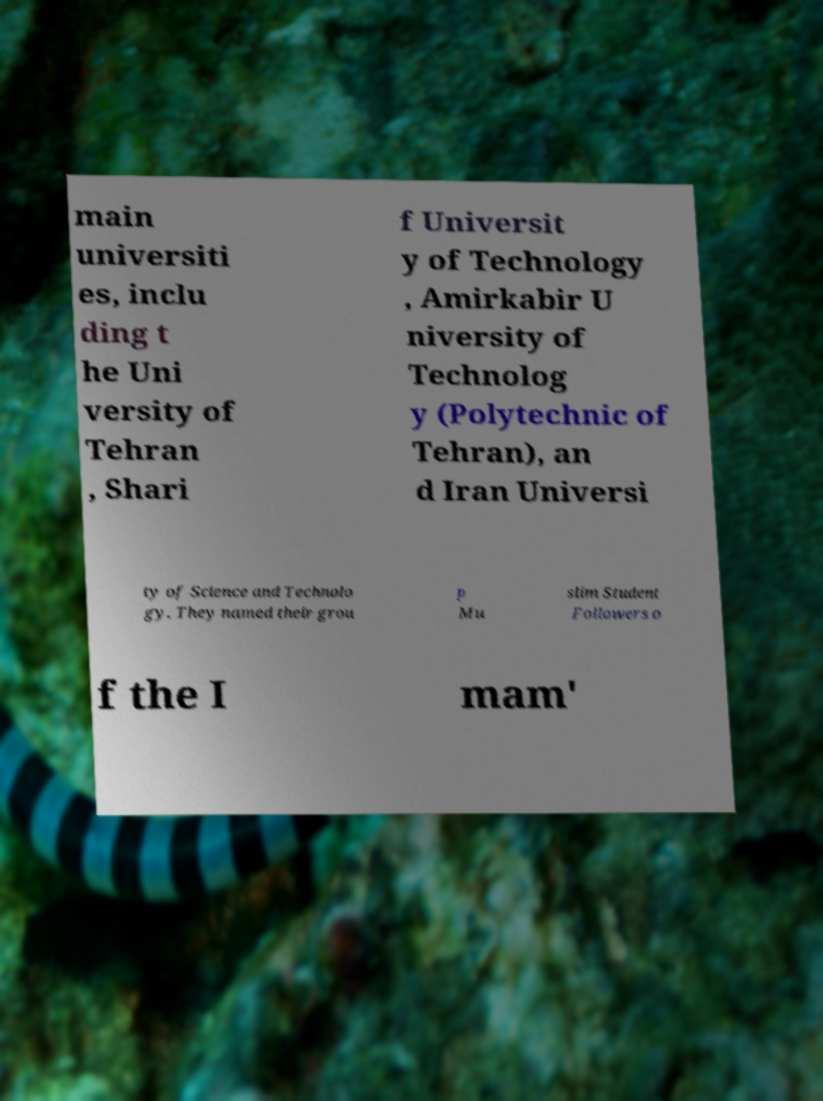I need the written content from this picture converted into text. Can you do that? main universiti es, inclu ding t he Uni versity of Tehran , Shari f Universit y of Technology , Amirkabir U niversity of Technolog y (Polytechnic of Tehran), an d Iran Universi ty of Science and Technolo gy. They named their grou p Mu slim Student Followers o f the I mam' 